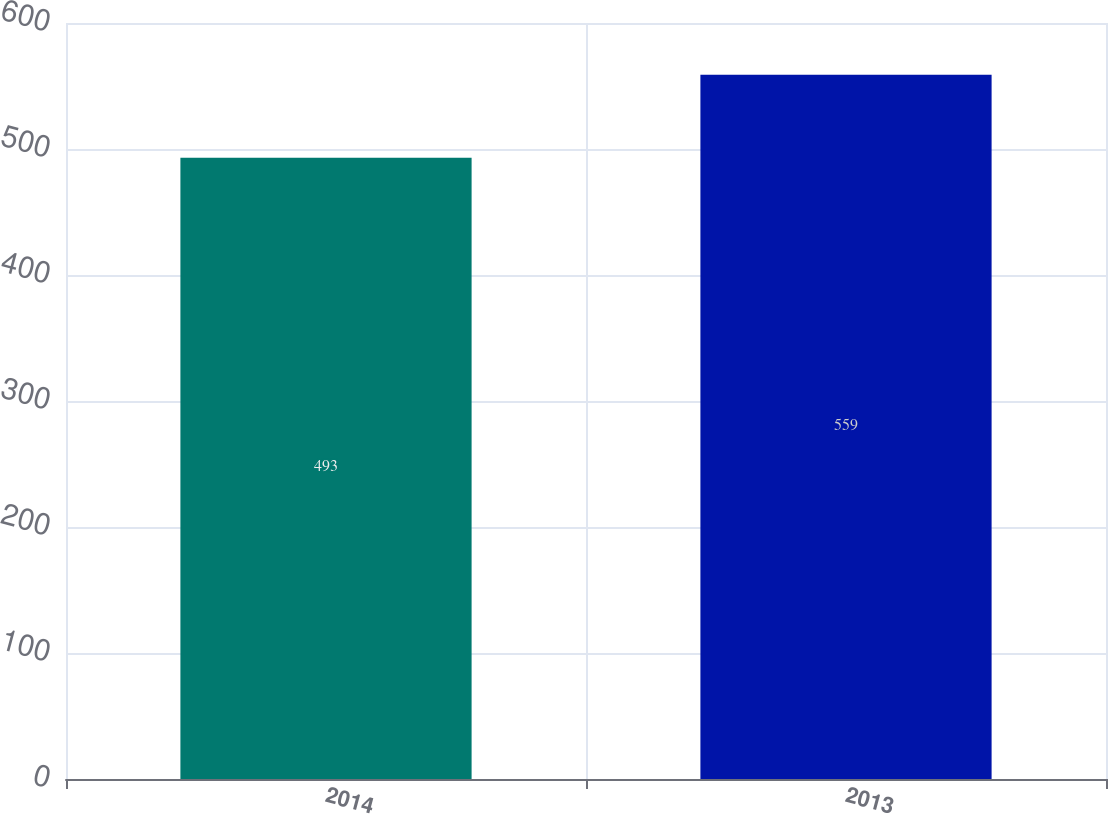Convert chart. <chart><loc_0><loc_0><loc_500><loc_500><bar_chart><fcel>2014<fcel>2013<nl><fcel>493<fcel>559<nl></chart> 